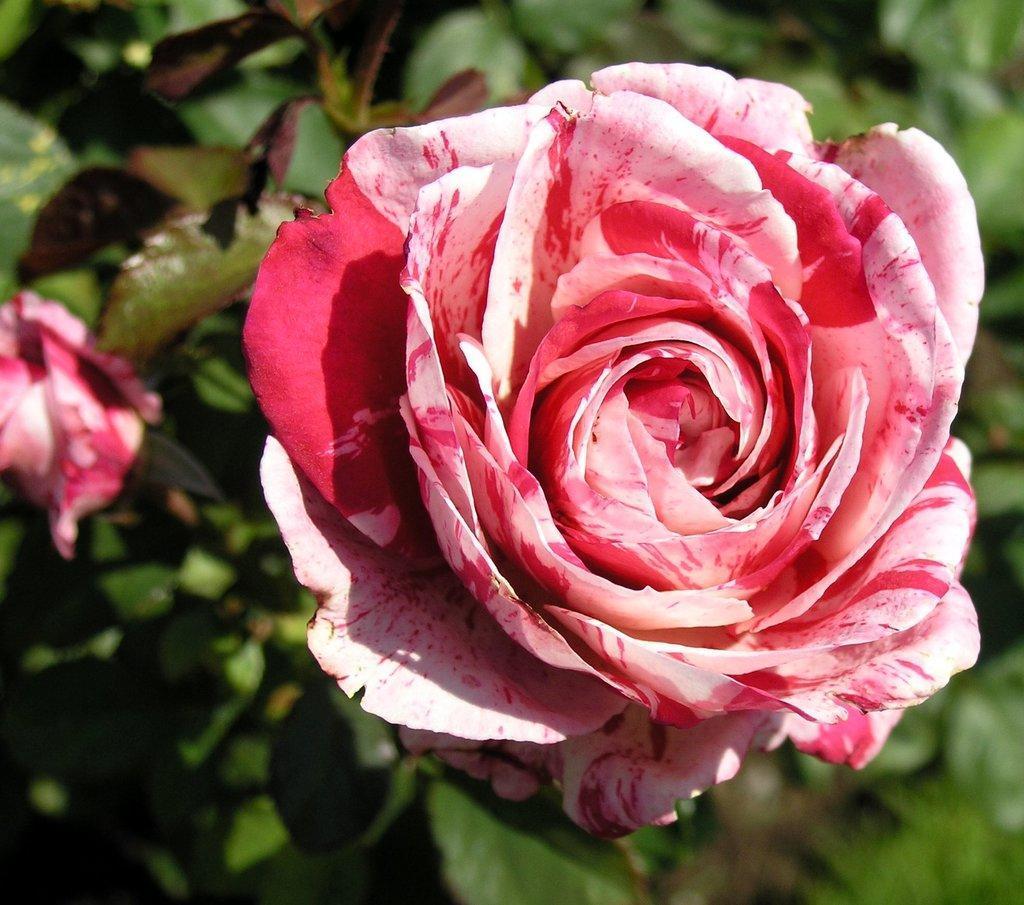Can you describe this image briefly? In this image there is a plant with two flowers, and there is blur background. 